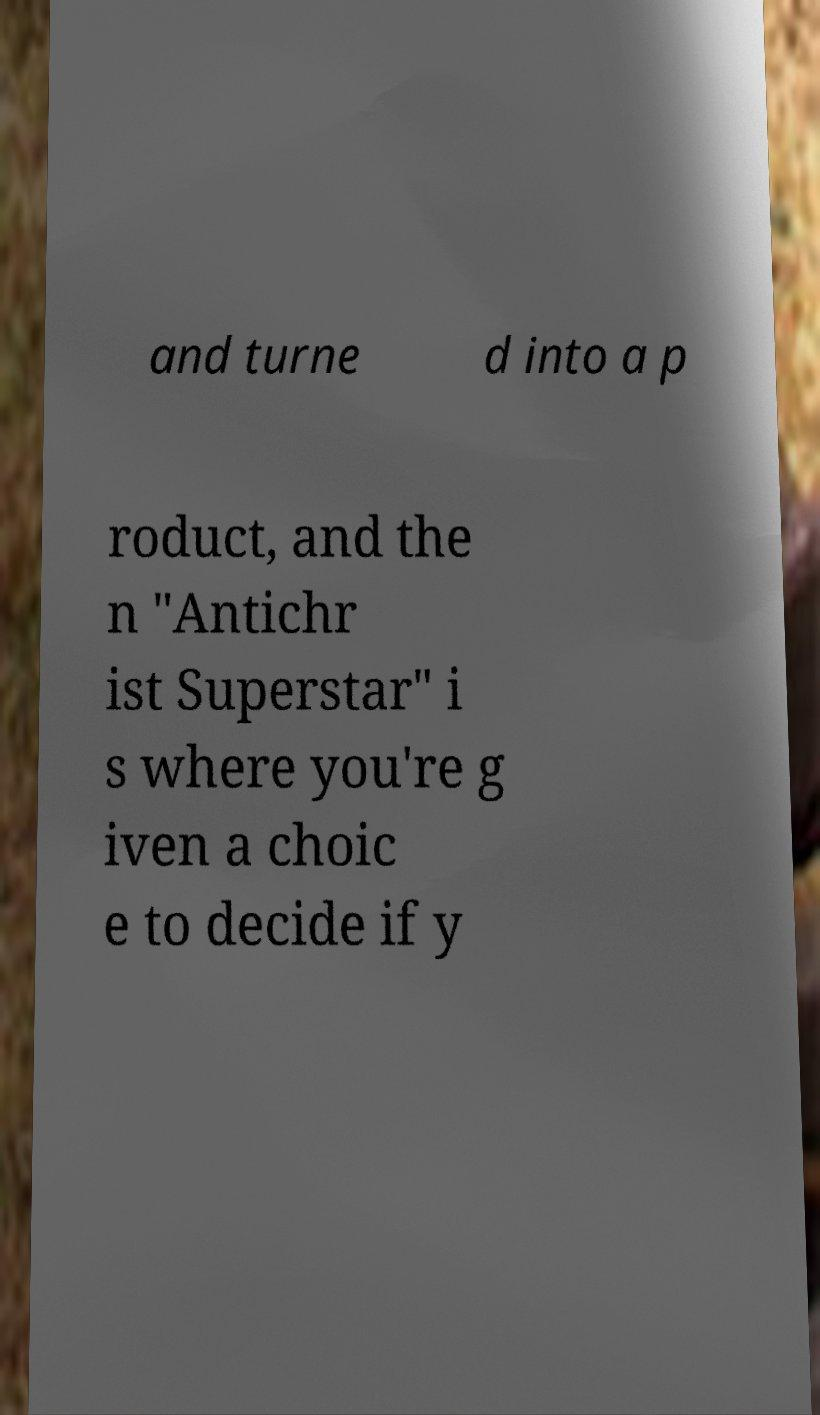What messages or text are displayed in this image? I need them in a readable, typed format. and turne d into a p roduct, and the n "Antichr ist Superstar" i s where you're g iven a choic e to decide if y 